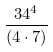<formula> <loc_0><loc_0><loc_500><loc_500>\frac { 3 4 ^ { 4 } } { ( 4 \cdot 7 ) }</formula> 